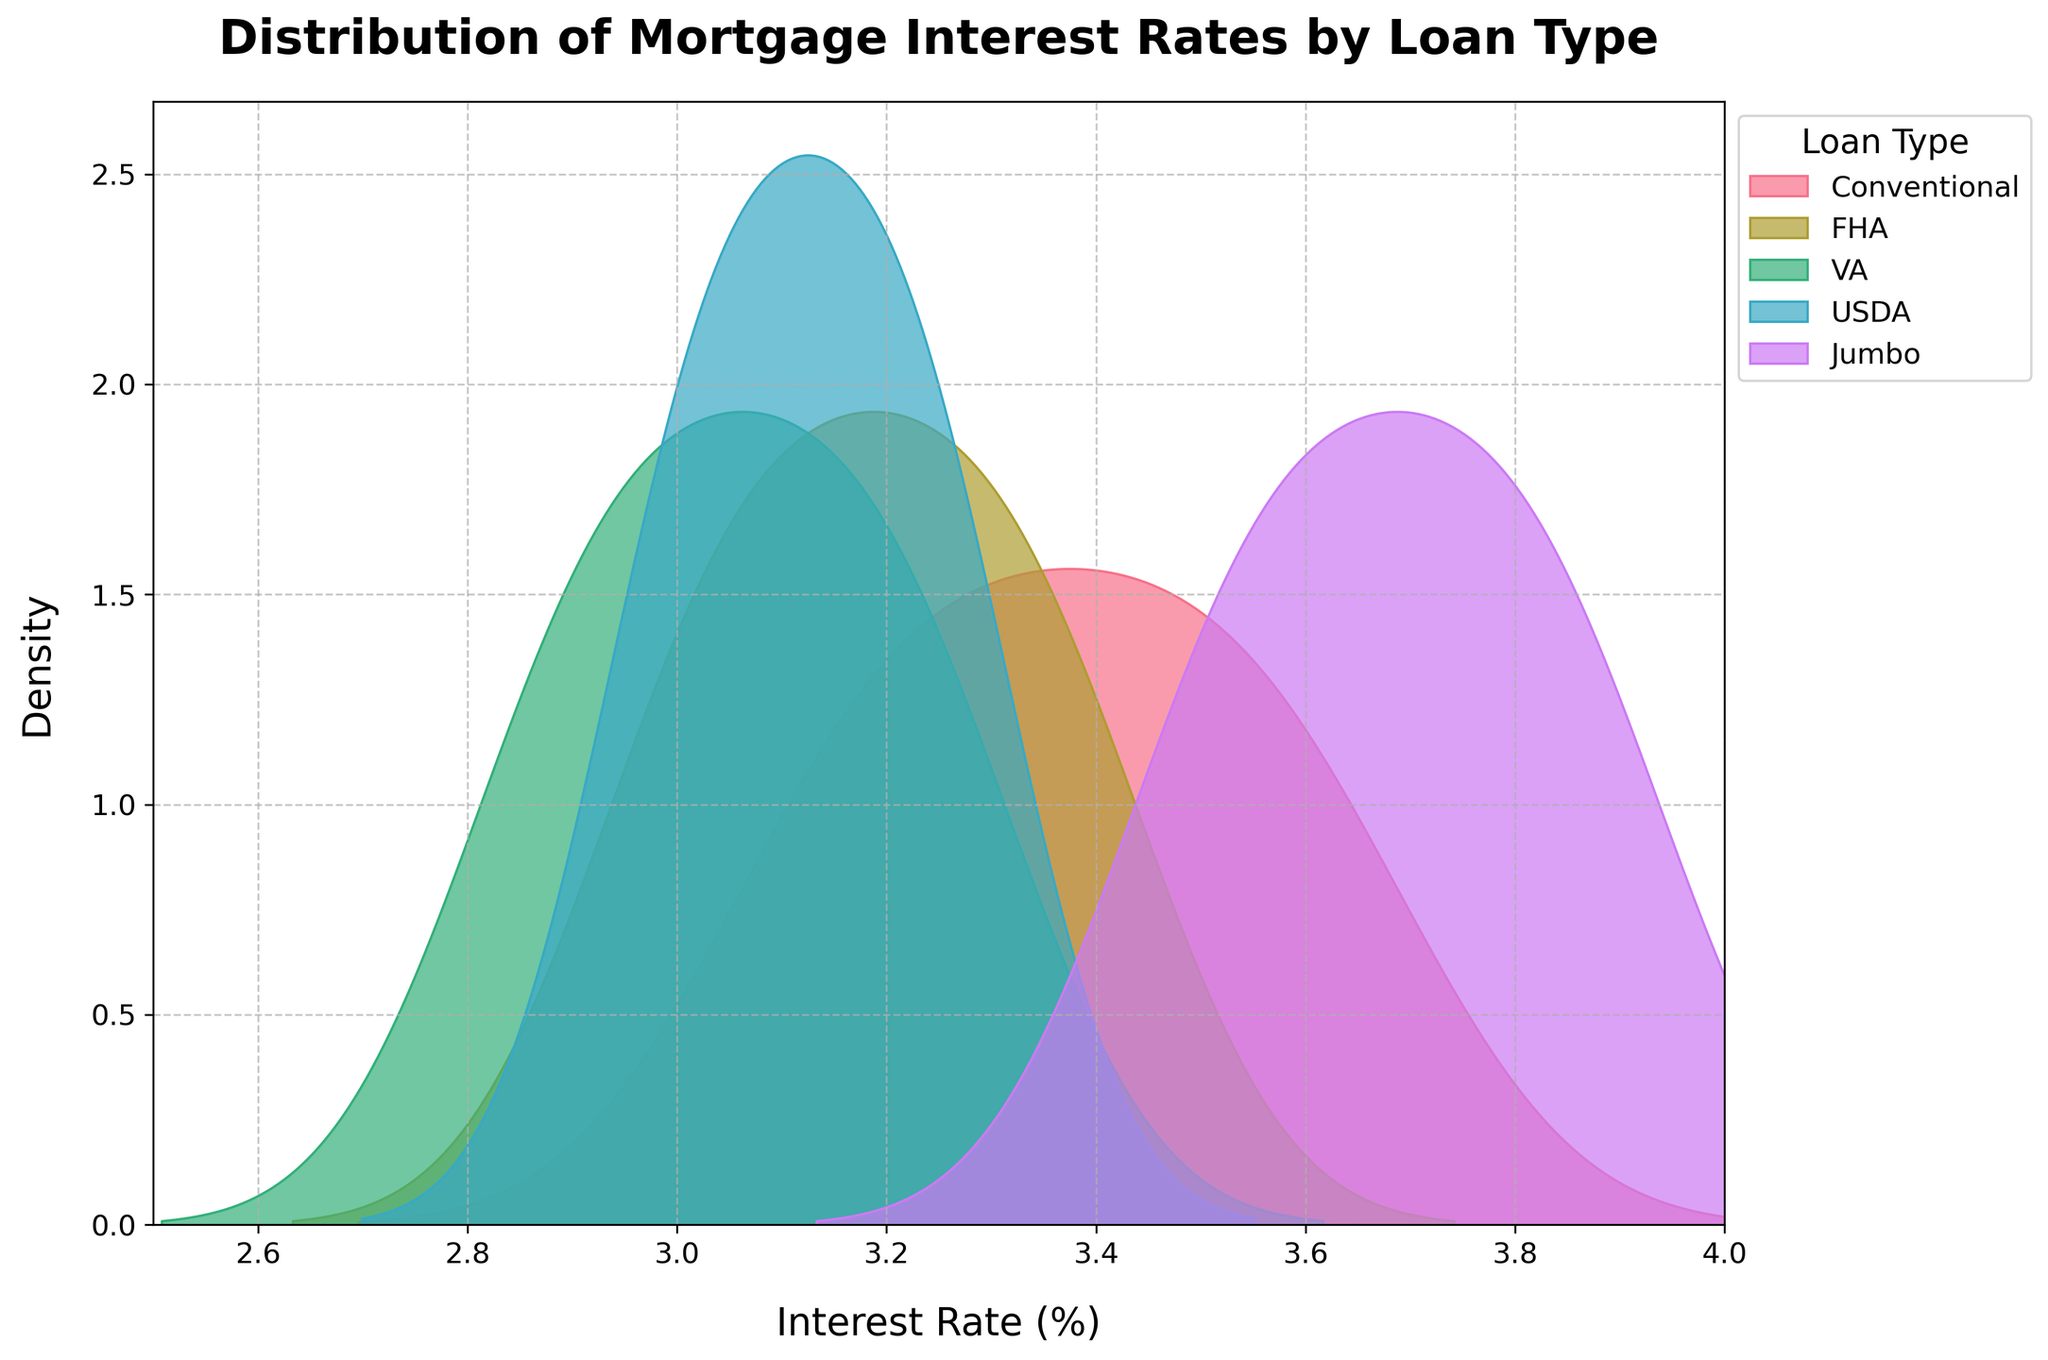What is the title of the figure? The title is written at the top of the figure and summarizes what the plot is about. The title reads "Distribution of Mortgage Interest Rates by Loan Type".
Answer: Distribution of Mortgage Interest Rates by Loan Type Which loan type has the widest range of interest rates? By observing the width of the shaded density area for each loan type, the one that spans the widest range of interest rates seems to be "Jumbo".
Answer: Jumbo Are the interest rates for Conventional loans generally higher or lower than those for VA loans? Comparing the positions of the density curves along the x-axis, the Conventional loans curve is to the right of the VA loans curve, indicating that Conventional rates are generally higher.
Answer: Higher Which loan type shows the highest peak in the density plot? The height of the peak indicates the density of interest rates within a specific range. The loan type with the highest peak is "Conventional".
Answer: Conventional What is the x-axis range of the plot? The x-axis range is specified from 2.5 to 4.0 as seen on the axis limits marked on the plot.
Answer: 2.5 to 4.0 Between FHA and USDA loans, which one has a higher concentration of interest rates around 3.125%? The density curve for USDA appears taller and more concentrated around the 3.125% mark compared to the FHA curve, suggesting a higher concentration around this rate for USDA loans.
Answer: USDA Which loan types have their density curves overlapping significantly near 3.125%? Observing the density plot, it can be seen that the FHA, USDA, and Conventional loan types all have overlapping curves near the 3.125% interest rate.
Answer: FHA, USDA, and Conventional Does any loan type have a density curve that extends beyond a 3.75% interest rate? By looking at the density plots, only Jumbo loans have a density curve extending beyond the 3.75% interest rate mark.
Answer: Jumbo 